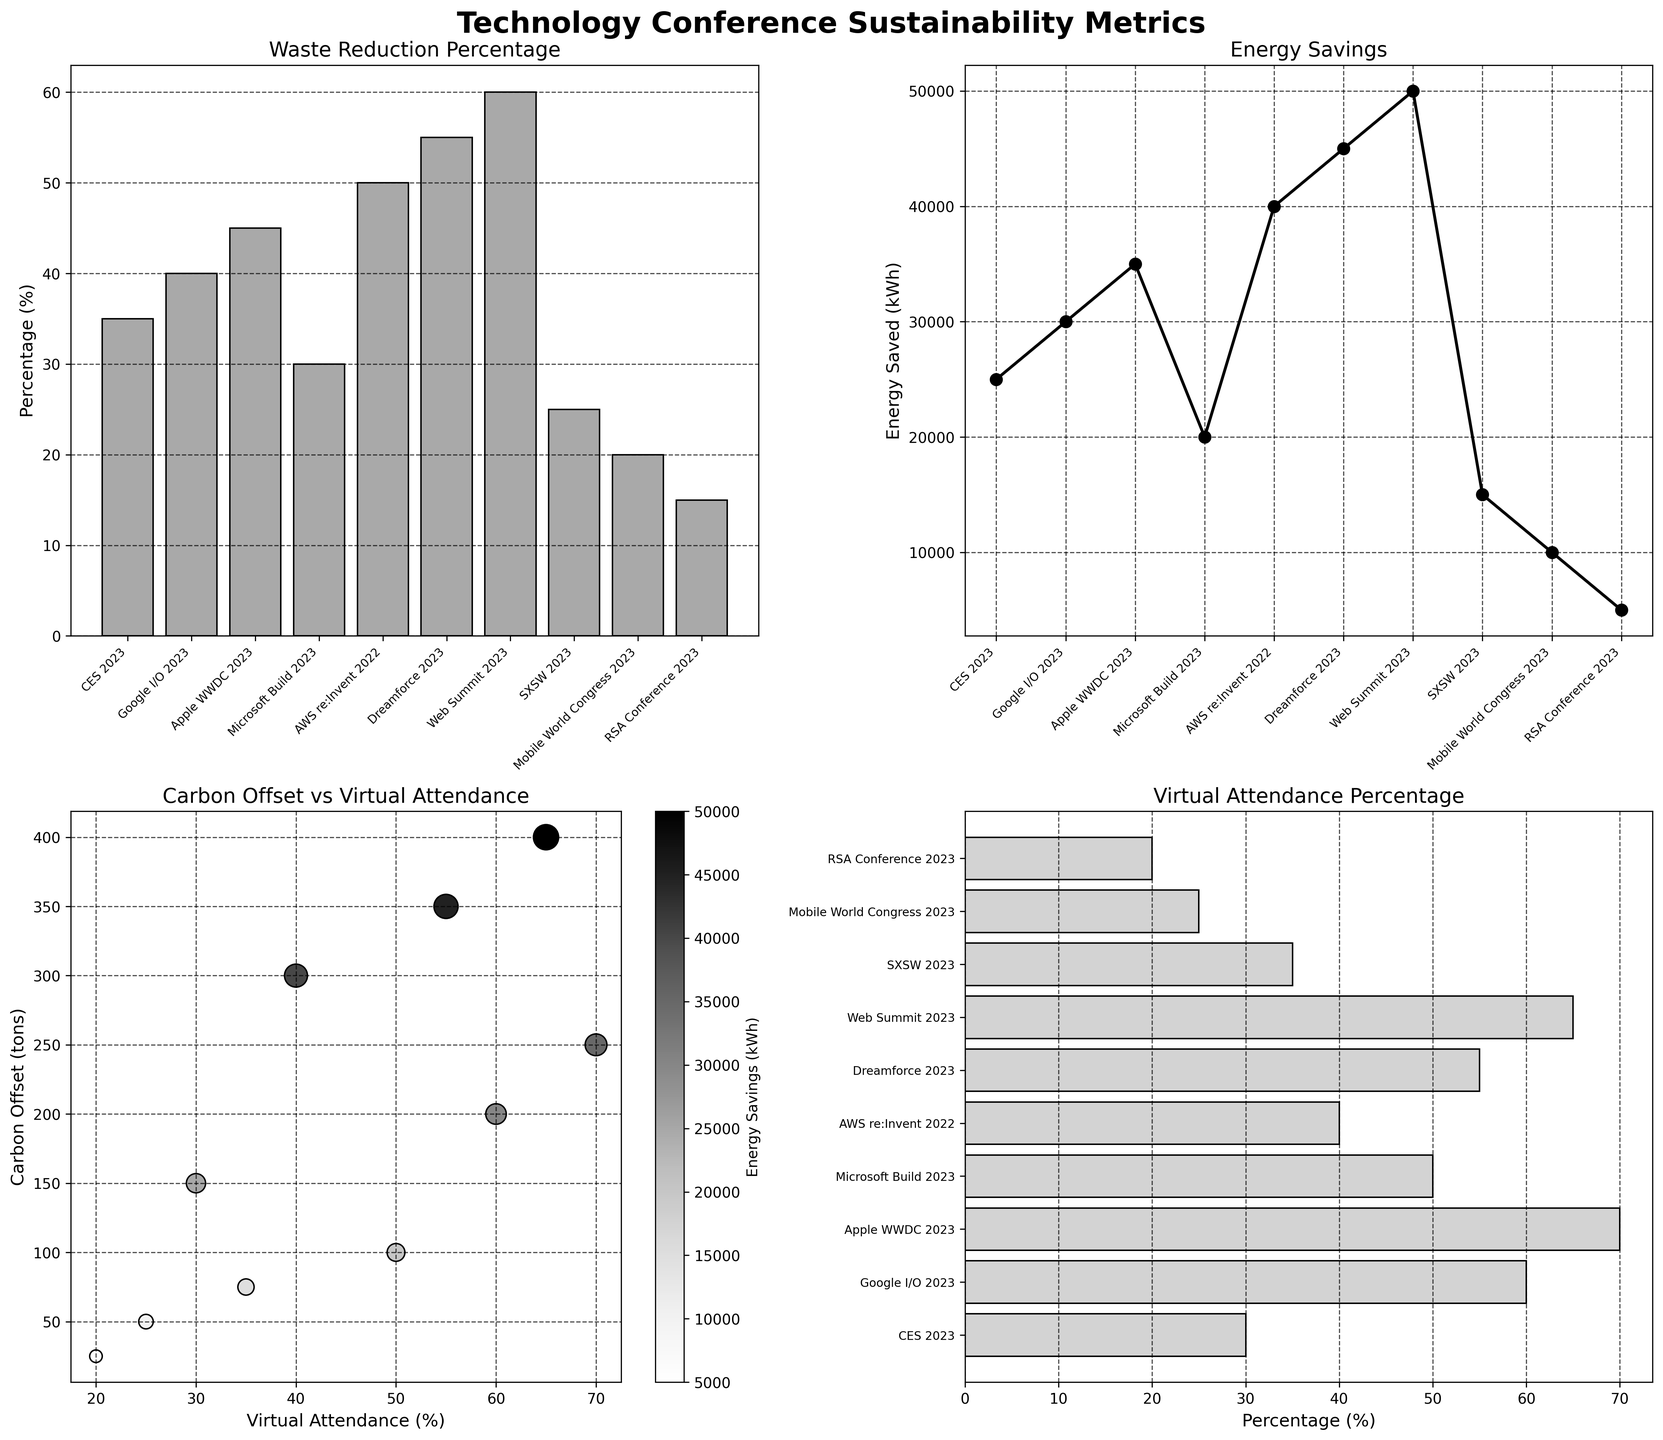What's the title of the figure? The title of the figure is located at the top and is the largest text element. It reads 'Technology Conference Sustainability Metrics'.
Answer: Technology Conference Sustainability Metrics Which conference achieved the highest waste reduction percentage? In the bar chart titled 'Waste Reduction Percentage', each conference is plotted on the x-axis. The highest bar corresponds to 'Web Summit 2023'.
Answer: Web Summit 2023 How much energy was saved during the CES 2023 conference? In the line plot titled 'Energy Savings', locate the point corresponding to 'CES 2023' and check the y-axis value for Energy Savings.
Answer: 25000 kWh What is the relationship between Virtual Attendance and Carbon Offset in general? From the scatter plot titled 'Carbon Offset vs Virtual Attendance', we can observe the trend that as Virtual Attendance increases, Carbon Offset tends to increase as well.
Answer: Positive correlation Which conference had the lowest carbon offset? In the scatter plot, the lowest point on the y-axis labeled 'Carbon Offset (tons)' is associated with the 'RSA Conference 2023'.
Answer: RSA Conference 2023 What’s the median value of Energy Savings among these conferences? In the line plot, list the Energy Savings values: 5000, 10000, 15000, 20000, 25000, 30000, 35000, 40000, 45000, 50000. The median value, being the middle value in a sorted list of these numbers, is 27500 (average of 25000 and 30000).
Answer: 27500 kWh Which conference has the highest percentage of virtual attendance? In the horizontal bar chart titled 'Virtual Attendance Percentage', the longest bar corresponds to 'Apple WWDC 2023'.
Answer: Apple WWDC 2023 How does the Energy Savings of AWS re:Invent compare to that of Dreamforce? In the line plot, the point for AWS re:Invent is at 40000 kWh, while Dreamforce is at 45000 kWh. Thus, Dreamforce saved more energy than AWS re:Invent.
Answer: Dreamforce is higher Within the scatter plot, which conference has the largest marker size? What does this indicate? The scatter plot shows the size of the marker represents the Waste Reduction percentage. The largest marker is for 'Web Summit 2023', indicating it had the highest waste reduction.
Answer: Web Summit 2023, highest waste reduction 